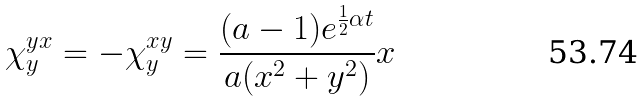Convert formula to latex. <formula><loc_0><loc_0><loc_500><loc_500>\chi _ { y } ^ { y x } = - \chi _ { y } ^ { x y } = \frac { ( a - 1 ) e ^ { \frac { 1 } { 2 } \alpha t } } { a ( x ^ { 2 } + y ^ { 2 } ) } x</formula> 